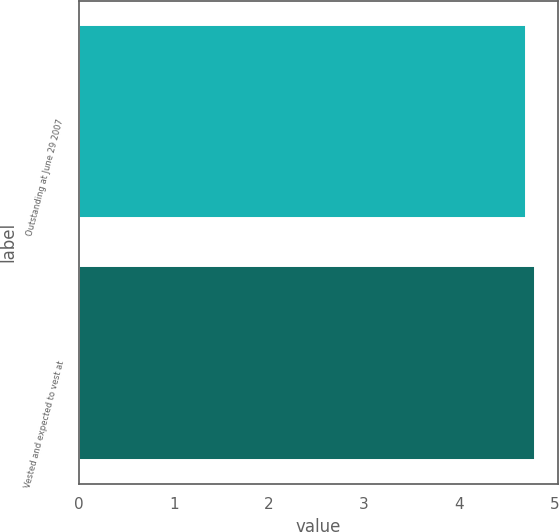Convert chart. <chart><loc_0><loc_0><loc_500><loc_500><bar_chart><fcel>Outstanding at June 29 2007<fcel>Vested and expected to vest at<nl><fcel>4.7<fcel>4.8<nl></chart> 